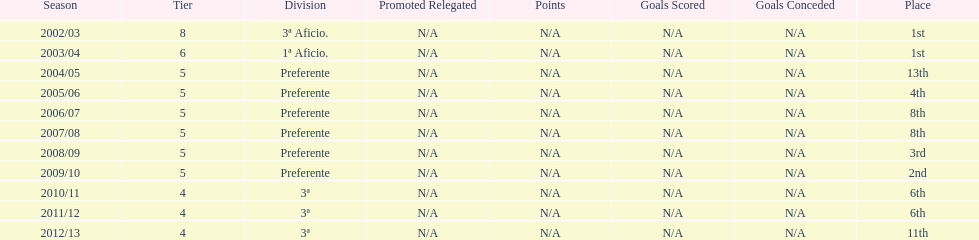What was the number of wins for preferente? 6. 